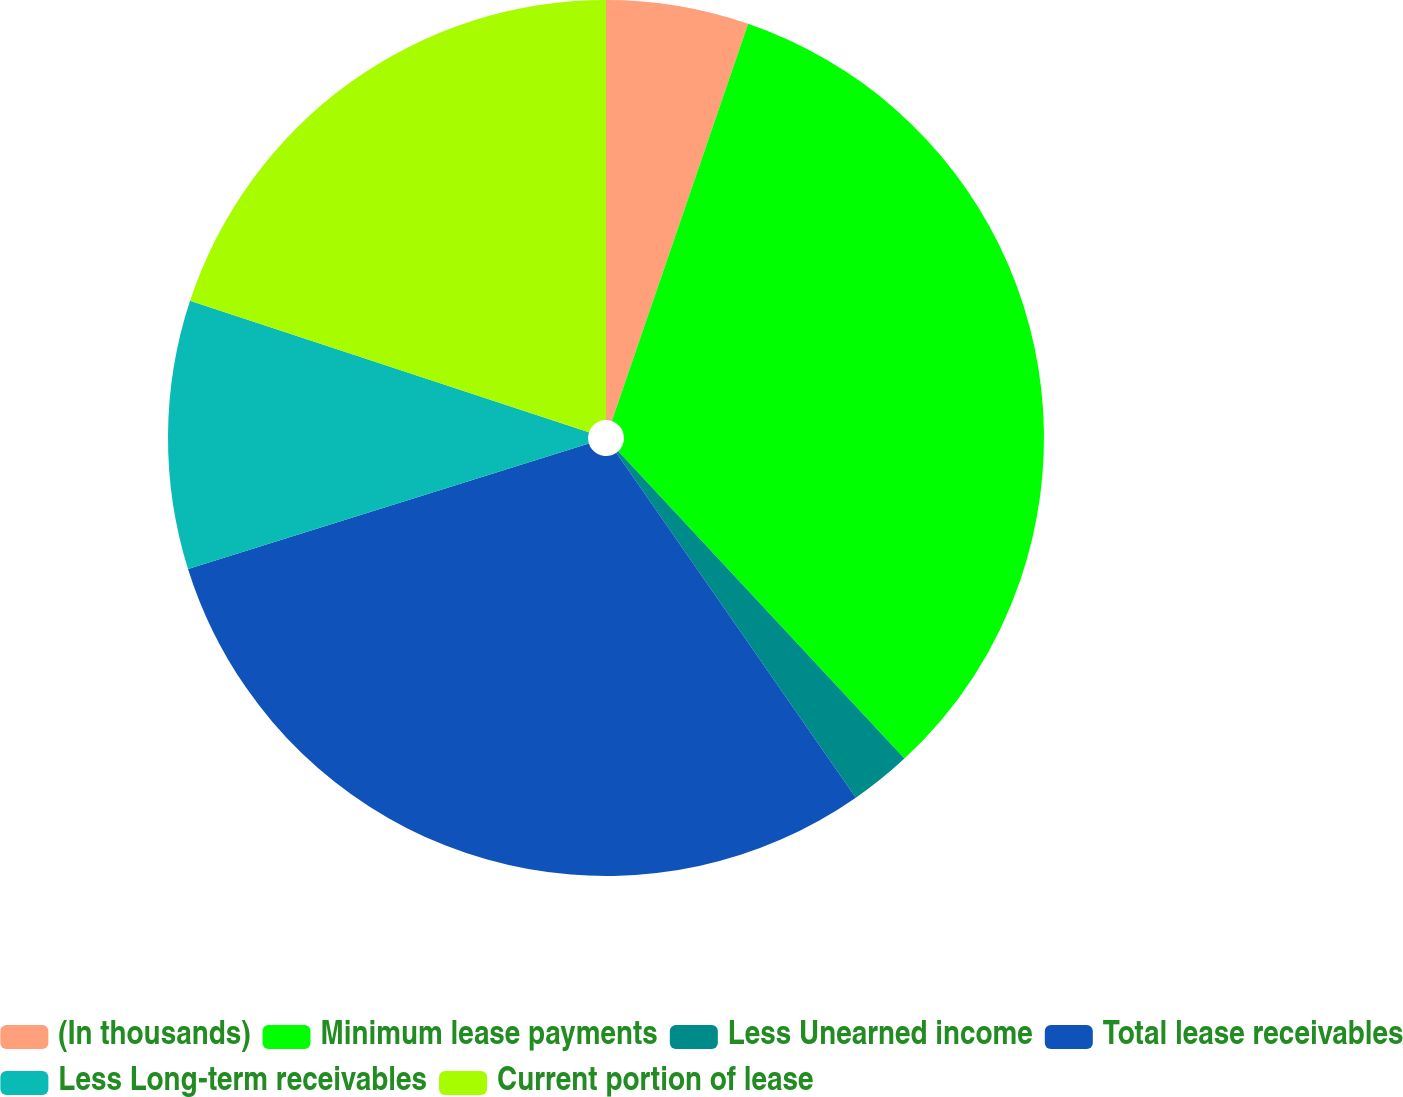<chart> <loc_0><loc_0><loc_500><loc_500><pie_chart><fcel>(In thousands)<fcel>Minimum lease payments<fcel>Less Unearned income<fcel>Total lease receivables<fcel>Less Long-term receivables<fcel>Current portion of lease<nl><fcel>5.26%<fcel>32.81%<fcel>2.27%<fcel>29.83%<fcel>9.9%<fcel>19.93%<nl></chart> 